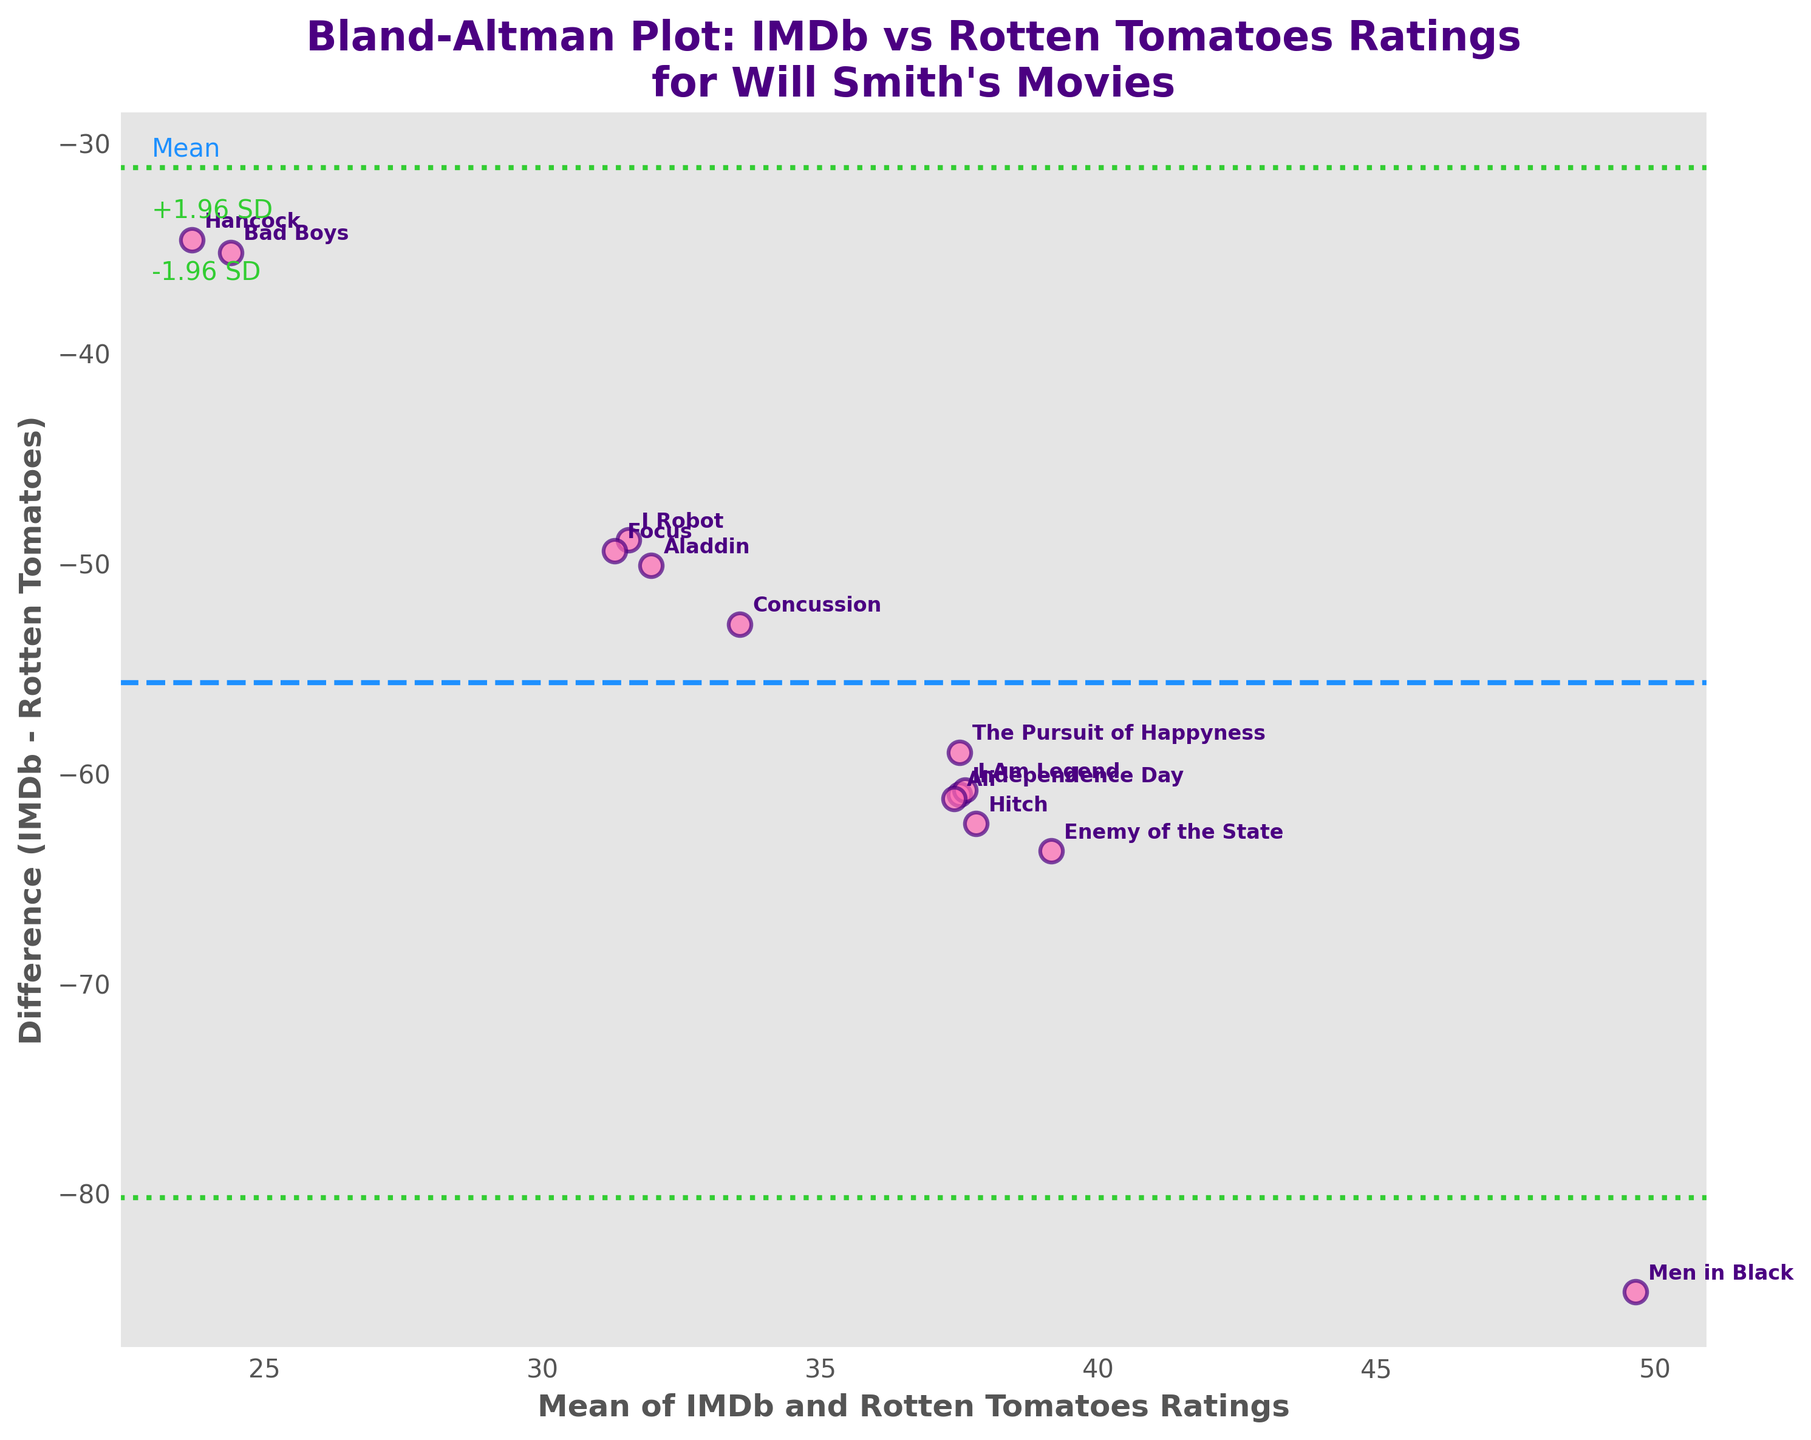What is the title of the plot? The title is generally located at the top of the plot and summarizes what the plot represents.
Answer: Bland-Altman Plot: IMDb vs Rotten Tomatoes Ratings for Will Smith's Movies What are the two metrics compared in the plot? Checking the labels on both axes reveals the metrics being compared.
Answer: IMDb and Rotten Tomatoes Ratings How are the data points visually represented in the plot? By observing the scatter plot, one can determine how each data point is displayed.
Answer: Pink circles with purple edges What does the dashed blue line represent? Examining the annotation and context of the dashed line can provide insight into its significance.
Answer: The mean difference between IMDb and Rotten Tomatoes ratings Which movie has the highest positive difference between IMDb and Rotten Tomatoes ratings? Look for the movie that appears furthest above the zero line on the y-axis.
Answer: Men in Black Which movie has the closest rating between IMDb and Rotten Tomatoes? Identify the movie whose data point is nearest to the zero line on the y-axis.
Answer: Ali What is the mean difference (IMDb - Rotten Tomatoes ratings)? The dashed blue line represents the mean difference.
Answer: Approximately -37 Are there any movies rated more favorably on Rotten Tomatoes than IMDb? Look for data points below the zero line on the y-axis.
Answer: Yes Is there a movie rated very differently on both platforms, where one rating is much higher than the other? Identify movies with data points far from the zero line, indicating a large difference.
Answer: Men in Black How does 'The Pursuit of Happyness' compare between the two platforms? Check the position of 'The Pursuit of Happyness' data point and its x-axis and y-axis values.
Answer: IMDb is significantly lower than Rotten Tomatoes Would you consider 'Hancock' a movie with similar or dissimilar ratings on both platforms? Compare the position of 'Hancock's data point relative to the zero line.
Answer: Dissimilar Is the mean difference between IMDb and Rotten Tomatoes positive or negative? The position of the blue dashed line relative to zero will indicate this.
Answer: Negative 